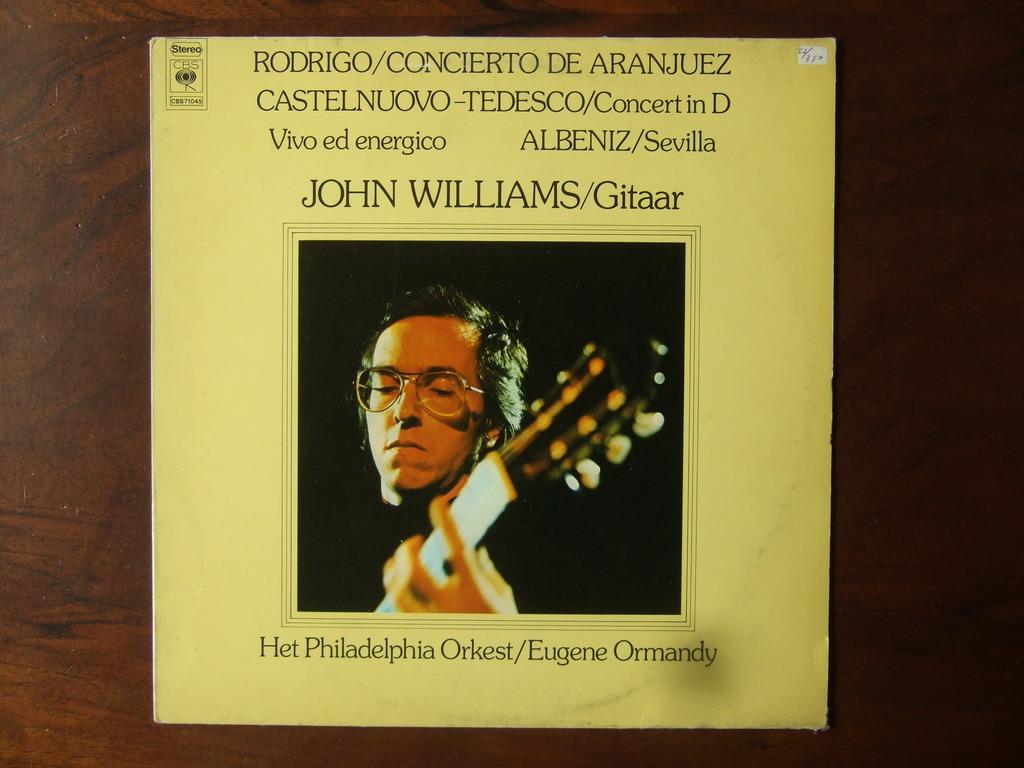Is this a famous guitarist?
Offer a terse response. Answering does not require reading text in the image. What us city is shown on this album?
Provide a succinct answer. Philadelphia. 